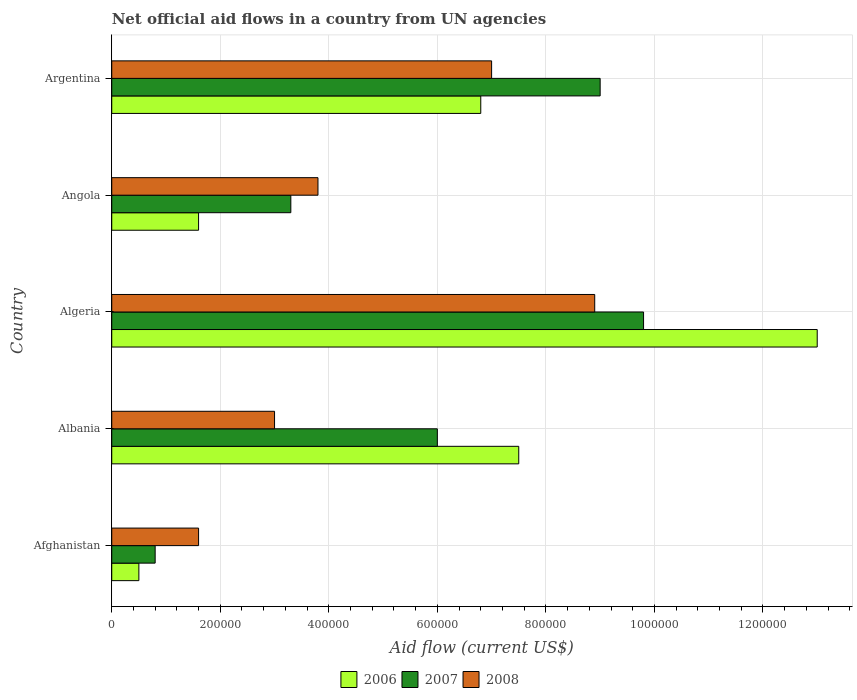How many bars are there on the 4th tick from the top?
Keep it short and to the point. 3. What is the label of the 2nd group of bars from the top?
Your answer should be very brief. Angola. Across all countries, what is the maximum net official aid flow in 2006?
Make the answer very short. 1.30e+06. Across all countries, what is the minimum net official aid flow in 2006?
Offer a terse response. 5.00e+04. In which country was the net official aid flow in 2006 maximum?
Keep it short and to the point. Algeria. In which country was the net official aid flow in 2007 minimum?
Keep it short and to the point. Afghanistan. What is the total net official aid flow in 2007 in the graph?
Offer a terse response. 2.89e+06. What is the difference between the net official aid flow in 2007 in Argentina and the net official aid flow in 2008 in Afghanistan?
Provide a short and direct response. 7.40e+05. What is the average net official aid flow in 2008 per country?
Provide a succinct answer. 4.86e+05. What is the ratio of the net official aid flow in 2008 in Algeria to that in Angola?
Offer a terse response. 2.34. Is the difference between the net official aid flow in 2006 in Afghanistan and Argentina greater than the difference between the net official aid flow in 2007 in Afghanistan and Argentina?
Offer a terse response. Yes. What is the difference between the highest and the lowest net official aid flow in 2007?
Provide a succinct answer. 9.00e+05. In how many countries, is the net official aid flow in 2007 greater than the average net official aid flow in 2007 taken over all countries?
Provide a succinct answer. 3. Is the sum of the net official aid flow in 2007 in Algeria and Angola greater than the maximum net official aid flow in 2006 across all countries?
Give a very brief answer. Yes. What does the 1st bar from the bottom in Algeria represents?
Make the answer very short. 2006. How many bars are there?
Offer a very short reply. 15. Are all the bars in the graph horizontal?
Your answer should be very brief. Yes. How many countries are there in the graph?
Ensure brevity in your answer.  5. Does the graph contain any zero values?
Keep it short and to the point. No. Where does the legend appear in the graph?
Offer a terse response. Bottom center. How many legend labels are there?
Keep it short and to the point. 3. How are the legend labels stacked?
Provide a succinct answer. Horizontal. What is the title of the graph?
Your answer should be compact. Net official aid flows in a country from UN agencies. Does "1965" appear as one of the legend labels in the graph?
Make the answer very short. No. What is the label or title of the Y-axis?
Keep it short and to the point. Country. What is the Aid flow (current US$) in 2008 in Afghanistan?
Your response must be concise. 1.60e+05. What is the Aid flow (current US$) in 2006 in Albania?
Ensure brevity in your answer.  7.50e+05. What is the Aid flow (current US$) in 2007 in Albania?
Make the answer very short. 6.00e+05. What is the Aid flow (current US$) of 2006 in Algeria?
Your response must be concise. 1.30e+06. What is the Aid flow (current US$) of 2007 in Algeria?
Give a very brief answer. 9.80e+05. What is the Aid flow (current US$) of 2008 in Algeria?
Give a very brief answer. 8.90e+05. What is the Aid flow (current US$) in 2008 in Angola?
Your answer should be compact. 3.80e+05. What is the Aid flow (current US$) of 2006 in Argentina?
Provide a short and direct response. 6.80e+05. What is the Aid flow (current US$) in 2007 in Argentina?
Your answer should be compact. 9.00e+05. Across all countries, what is the maximum Aid flow (current US$) in 2006?
Offer a very short reply. 1.30e+06. Across all countries, what is the maximum Aid flow (current US$) in 2007?
Ensure brevity in your answer.  9.80e+05. Across all countries, what is the maximum Aid flow (current US$) in 2008?
Keep it short and to the point. 8.90e+05. Across all countries, what is the minimum Aid flow (current US$) of 2006?
Ensure brevity in your answer.  5.00e+04. What is the total Aid flow (current US$) of 2006 in the graph?
Offer a very short reply. 2.94e+06. What is the total Aid flow (current US$) of 2007 in the graph?
Offer a terse response. 2.89e+06. What is the total Aid flow (current US$) in 2008 in the graph?
Offer a terse response. 2.43e+06. What is the difference between the Aid flow (current US$) in 2006 in Afghanistan and that in Albania?
Ensure brevity in your answer.  -7.00e+05. What is the difference between the Aid flow (current US$) of 2007 in Afghanistan and that in Albania?
Your answer should be very brief. -5.20e+05. What is the difference between the Aid flow (current US$) in 2008 in Afghanistan and that in Albania?
Offer a very short reply. -1.40e+05. What is the difference between the Aid flow (current US$) of 2006 in Afghanistan and that in Algeria?
Your response must be concise. -1.25e+06. What is the difference between the Aid flow (current US$) of 2007 in Afghanistan and that in Algeria?
Provide a succinct answer. -9.00e+05. What is the difference between the Aid flow (current US$) of 2008 in Afghanistan and that in Algeria?
Give a very brief answer. -7.30e+05. What is the difference between the Aid flow (current US$) of 2006 in Afghanistan and that in Argentina?
Offer a very short reply. -6.30e+05. What is the difference between the Aid flow (current US$) of 2007 in Afghanistan and that in Argentina?
Offer a very short reply. -8.20e+05. What is the difference between the Aid flow (current US$) of 2008 in Afghanistan and that in Argentina?
Keep it short and to the point. -5.40e+05. What is the difference between the Aid flow (current US$) of 2006 in Albania and that in Algeria?
Your response must be concise. -5.50e+05. What is the difference between the Aid flow (current US$) in 2007 in Albania and that in Algeria?
Provide a short and direct response. -3.80e+05. What is the difference between the Aid flow (current US$) in 2008 in Albania and that in Algeria?
Keep it short and to the point. -5.90e+05. What is the difference between the Aid flow (current US$) of 2006 in Albania and that in Angola?
Your answer should be compact. 5.90e+05. What is the difference between the Aid flow (current US$) of 2006 in Albania and that in Argentina?
Your answer should be very brief. 7.00e+04. What is the difference between the Aid flow (current US$) of 2008 in Albania and that in Argentina?
Offer a terse response. -4.00e+05. What is the difference between the Aid flow (current US$) in 2006 in Algeria and that in Angola?
Your response must be concise. 1.14e+06. What is the difference between the Aid flow (current US$) in 2007 in Algeria and that in Angola?
Your answer should be very brief. 6.50e+05. What is the difference between the Aid flow (current US$) in 2008 in Algeria and that in Angola?
Ensure brevity in your answer.  5.10e+05. What is the difference between the Aid flow (current US$) of 2006 in Algeria and that in Argentina?
Ensure brevity in your answer.  6.20e+05. What is the difference between the Aid flow (current US$) in 2007 in Algeria and that in Argentina?
Your answer should be very brief. 8.00e+04. What is the difference between the Aid flow (current US$) of 2008 in Algeria and that in Argentina?
Offer a terse response. 1.90e+05. What is the difference between the Aid flow (current US$) in 2006 in Angola and that in Argentina?
Ensure brevity in your answer.  -5.20e+05. What is the difference between the Aid flow (current US$) in 2007 in Angola and that in Argentina?
Ensure brevity in your answer.  -5.70e+05. What is the difference between the Aid flow (current US$) of 2008 in Angola and that in Argentina?
Offer a very short reply. -3.20e+05. What is the difference between the Aid flow (current US$) of 2006 in Afghanistan and the Aid flow (current US$) of 2007 in Albania?
Your answer should be compact. -5.50e+05. What is the difference between the Aid flow (current US$) of 2006 in Afghanistan and the Aid flow (current US$) of 2008 in Albania?
Ensure brevity in your answer.  -2.50e+05. What is the difference between the Aid flow (current US$) of 2007 in Afghanistan and the Aid flow (current US$) of 2008 in Albania?
Ensure brevity in your answer.  -2.20e+05. What is the difference between the Aid flow (current US$) of 2006 in Afghanistan and the Aid flow (current US$) of 2007 in Algeria?
Your response must be concise. -9.30e+05. What is the difference between the Aid flow (current US$) in 2006 in Afghanistan and the Aid flow (current US$) in 2008 in Algeria?
Make the answer very short. -8.40e+05. What is the difference between the Aid flow (current US$) in 2007 in Afghanistan and the Aid flow (current US$) in 2008 in Algeria?
Your answer should be very brief. -8.10e+05. What is the difference between the Aid flow (current US$) in 2006 in Afghanistan and the Aid flow (current US$) in 2007 in Angola?
Provide a short and direct response. -2.80e+05. What is the difference between the Aid flow (current US$) in 2006 in Afghanistan and the Aid flow (current US$) in 2008 in Angola?
Your answer should be very brief. -3.30e+05. What is the difference between the Aid flow (current US$) in 2006 in Afghanistan and the Aid flow (current US$) in 2007 in Argentina?
Your answer should be compact. -8.50e+05. What is the difference between the Aid flow (current US$) in 2006 in Afghanistan and the Aid flow (current US$) in 2008 in Argentina?
Give a very brief answer. -6.50e+05. What is the difference between the Aid flow (current US$) in 2007 in Afghanistan and the Aid flow (current US$) in 2008 in Argentina?
Ensure brevity in your answer.  -6.20e+05. What is the difference between the Aid flow (current US$) in 2006 in Albania and the Aid flow (current US$) in 2007 in Algeria?
Ensure brevity in your answer.  -2.30e+05. What is the difference between the Aid flow (current US$) in 2006 in Albania and the Aid flow (current US$) in 2007 in Argentina?
Your answer should be very brief. -1.50e+05. What is the difference between the Aid flow (current US$) of 2006 in Albania and the Aid flow (current US$) of 2008 in Argentina?
Make the answer very short. 5.00e+04. What is the difference between the Aid flow (current US$) of 2006 in Algeria and the Aid flow (current US$) of 2007 in Angola?
Offer a terse response. 9.70e+05. What is the difference between the Aid flow (current US$) of 2006 in Algeria and the Aid flow (current US$) of 2008 in Angola?
Make the answer very short. 9.20e+05. What is the difference between the Aid flow (current US$) of 2006 in Algeria and the Aid flow (current US$) of 2007 in Argentina?
Give a very brief answer. 4.00e+05. What is the difference between the Aid flow (current US$) in 2006 in Algeria and the Aid flow (current US$) in 2008 in Argentina?
Offer a very short reply. 6.00e+05. What is the difference between the Aid flow (current US$) of 2006 in Angola and the Aid flow (current US$) of 2007 in Argentina?
Your answer should be very brief. -7.40e+05. What is the difference between the Aid flow (current US$) of 2006 in Angola and the Aid flow (current US$) of 2008 in Argentina?
Provide a succinct answer. -5.40e+05. What is the difference between the Aid flow (current US$) in 2007 in Angola and the Aid flow (current US$) in 2008 in Argentina?
Your answer should be compact. -3.70e+05. What is the average Aid flow (current US$) of 2006 per country?
Keep it short and to the point. 5.88e+05. What is the average Aid flow (current US$) of 2007 per country?
Make the answer very short. 5.78e+05. What is the average Aid flow (current US$) in 2008 per country?
Offer a terse response. 4.86e+05. What is the difference between the Aid flow (current US$) in 2006 and Aid flow (current US$) in 2007 in Afghanistan?
Provide a short and direct response. -3.00e+04. What is the difference between the Aid flow (current US$) of 2006 and Aid flow (current US$) of 2008 in Afghanistan?
Keep it short and to the point. -1.10e+05. What is the difference between the Aid flow (current US$) in 2007 and Aid flow (current US$) in 2008 in Afghanistan?
Make the answer very short. -8.00e+04. What is the difference between the Aid flow (current US$) in 2006 and Aid flow (current US$) in 2007 in Albania?
Make the answer very short. 1.50e+05. What is the difference between the Aid flow (current US$) in 2006 and Aid flow (current US$) in 2008 in Albania?
Offer a very short reply. 4.50e+05. What is the difference between the Aid flow (current US$) of 2006 and Aid flow (current US$) of 2008 in Algeria?
Provide a short and direct response. 4.10e+05. What is the difference between the Aid flow (current US$) of 2007 and Aid flow (current US$) of 2008 in Angola?
Give a very brief answer. -5.00e+04. What is the difference between the Aid flow (current US$) in 2006 and Aid flow (current US$) in 2007 in Argentina?
Keep it short and to the point. -2.20e+05. What is the difference between the Aid flow (current US$) in 2007 and Aid flow (current US$) in 2008 in Argentina?
Your answer should be very brief. 2.00e+05. What is the ratio of the Aid flow (current US$) in 2006 in Afghanistan to that in Albania?
Your answer should be compact. 0.07. What is the ratio of the Aid flow (current US$) of 2007 in Afghanistan to that in Albania?
Your response must be concise. 0.13. What is the ratio of the Aid flow (current US$) of 2008 in Afghanistan to that in Albania?
Your answer should be compact. 0.53. What is the ratio of the Aid flow (current US$) in 2006 in Afghanistan to that in Algeria?
Give a very brief answer. 0.04. What is the ratio of the Aid flow (current US$) in 2007 in Afghanistan to that in Algeria?
Your response must be concise. 0.08. What is the ratio of the Aid flow (current US$) of 2008 in Afghanistan to that in Algeria?
Make the answer very short. 0.18. What is the ratio of the Aid flow (current US$) of 2006 in Afghanistan to that in Angola?
Keep it short and to the point. 0.31. What is the ratio of the Aid flow (current US$) of 2007 in Afghanistan to that in Angola?
Offer a terse response. 0.24. What is the ratio of the Aid flow (current US$) in 2008 in Afghanistan to that in Angola?
Your answer should be compact. 0.42. What is the ratio of the Aid flow (current US$) of 2006 in Afghanistan to that in Argentina?
Keep it short and to the point. 0.07. What is the ratio of the Aid flow (current US$) in 2007 in Afghanistan to that in Argentina?
Your answer should be compact. 0.09. What is the ratio of the Aid flow (current US$) of 2008 in Afghanistan to that in Argentina?
Provide a short and direct response. 0.23. What is the ratio of the Aid flow (current US$) in 2006 in Albania to that in Algeria?
Your response must be concise. 0.58. What is the ratio of the Aid flow (current US$) in 2007 in Albania to that in Algeria?
Ensure brevity in your answer.  0.61. What is the ratio of the Aid flow (current US$) in 2008 in Albania to that in Algeria?
Give a very brief answer. 0.34. What is the ratio of the Aid flow (current US$) in 2006 in Albania to that in Angola?
Make the answer very short. 4.69. What is the ratio of the Aid flow (current US$) of 2007 in Albania to that in Angola?
Your response must be concise. 1.82. What is the ratio of the Aid flow (current US$) of 2008 in Albania to that in Angola?
Make the answer very short. 0.79. What is the ratio of the Aid flow (current US$) of 2006 in Albania to that in Argentina?
Give a very brief answer. 1.1. What is the ratio of the Aid flow (current US$) of 2008 in Albania to that in Argentina?
Make the answer very short. 0.43. What is the ratio of the Aid flow (current US$) in 2006 in Algeria to that in Angola?
Your answer should be very brief. 8.12. What is the ratio of the Aid flow (current US$) of 2007 in Algeria to that in Angola?
Your answer should be very brief. 2.97. What is the ratio of the Aid flow (current US$) of 2008 in Algeria to that in Angola?
Provide a short and direct response. 2.34. What is the ratio of the Aid flow (current US$) of 2006 in Algeria to that in Argentina?
Make the answer very short. 1.91. What is the ratio of the Aid flow (current US$) of 2007 in Algeria to that in Argentina?
Your answer should be compact. 1.09. What is the ratio of the Aid flow (current US$) in 2008 in Algeria to that in Argentina?
Make the answer very short. 1.27. What is the ratio of the Aid flow (current US$) in 2006 in Angola to that in Argentina?
Offer a very short reply. 0.24. What is the ratio of the Aid flow (current US$) of 2007 in Angola to that in Argentina?
Your response must be concise. 0.37. What is the ratio of the Aid flow (current US$) in 2008 in Angola to that in Argentina?
Provide a succinct answer. 0.54. What is the difference between the highest and the second highest Aid flow (current US$) in 2007?
Keep it short and to the point. 8.00e+04. What is the difference between the highest and the second highest Aid flow (current US$) in 2008?
Your answer should be compact. 1.90e+05. What is the difference between the highest and the lowest Aid flow (current US$) in 2006?
Keep it short and to the point. 1.25e+06. What is the difference between the highest and the lowest Aid flow (current US$) in 2008?
Keep it short and to the point. 7.30e+05. 